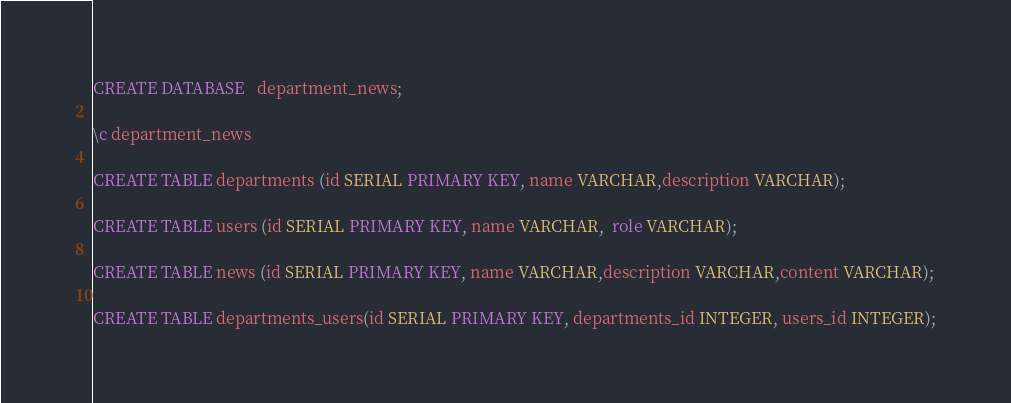Convert code to text. <code><loc_0><loc_0><loc_500><loc_500><_SQL_>CREATE DATABASE   department_news;

\c department_news

CREATE TABLE departments (id SERIAL PRIMARY KEY, name VARCHAR,description VARCHAR);

CREATE TABLE users (id SERIAL PRIMARY KEY, name VARCHAR,  role VARCHAR);

CREATE TABLE news (id SERIAL PRIMARY KEY, name VARCHAR,description VARCHAR,content VARCHAR);

CREATE TABLE departments_users(id SERIAL PRIMARY KEY, departments_id INTEGER, users_id INTEGER);




</code> 